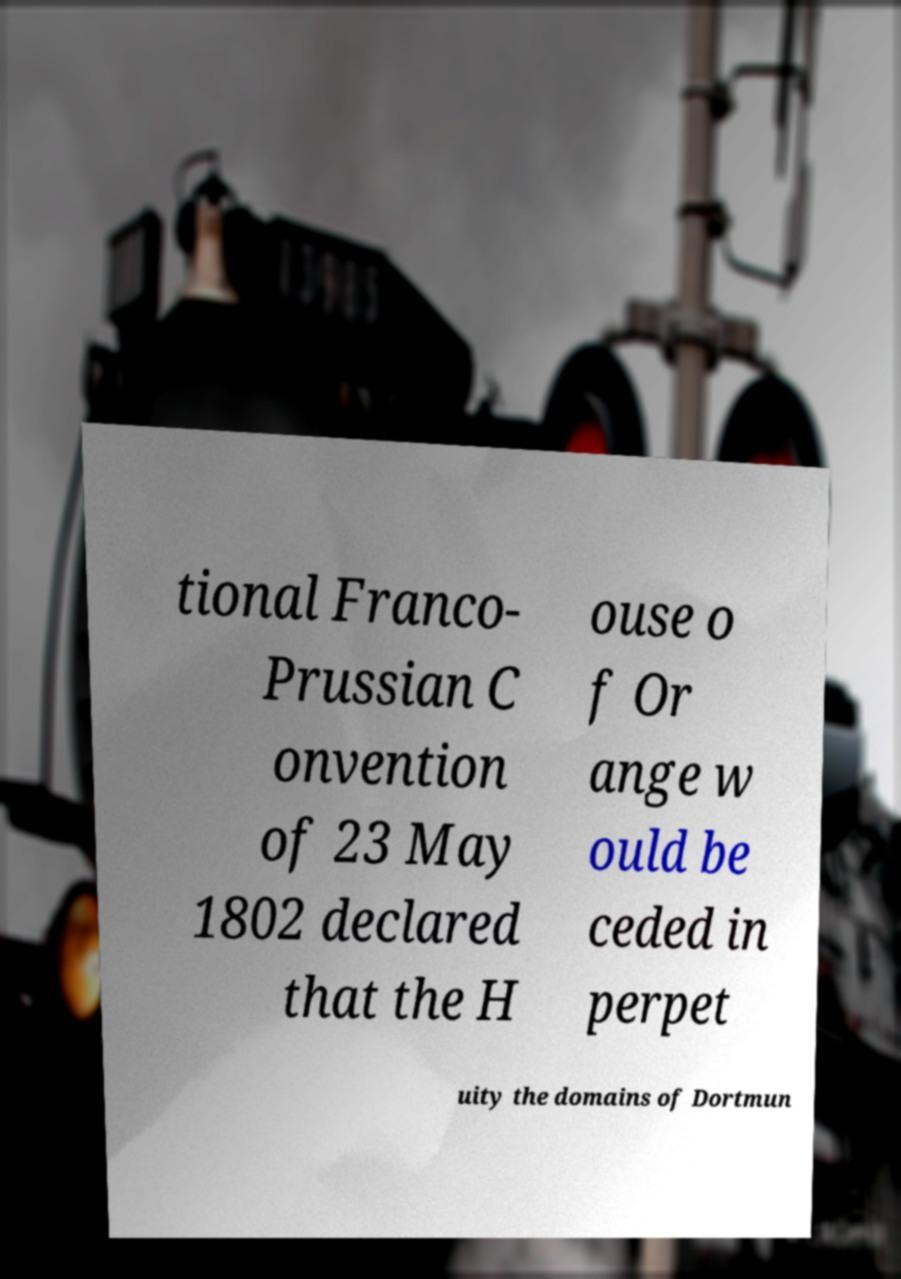Could you assist in decoding the text presented in this image and type it out clearly? tional Franco- Prussian C onvention of 23 May 1802 declared that the H ouse o f Or ange w ould be ceded in perpet uity the domains of Dortmun 